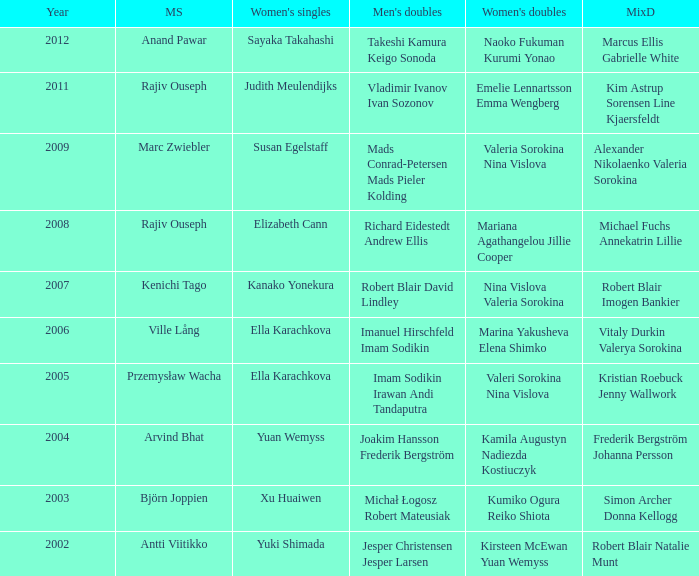What is the mens singles of 2008? Rajiv Ouseph. 